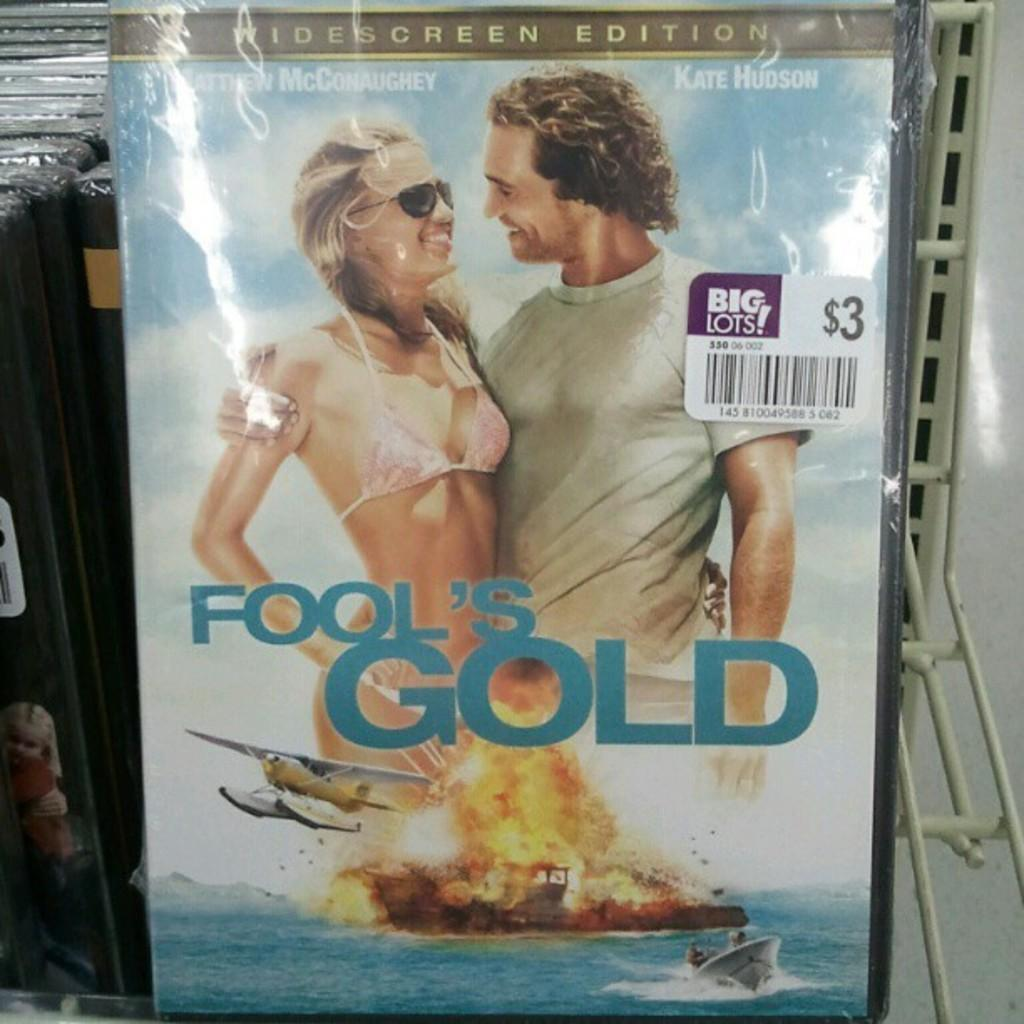Provide a one-sentence caption for the provided image. A copy of Fool's Gold is only $3 at Big Lots. 